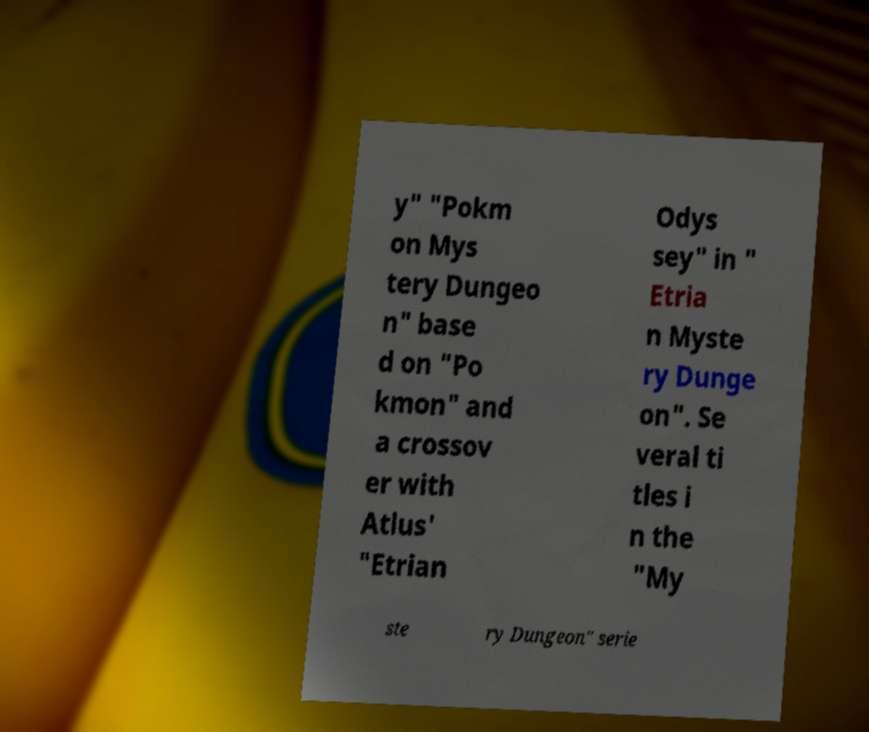Please read and relay the text visible in this image. What does it say? y" "Pokm on Mys tery Dungeo n" base d on "Po kmon" and a crossov er with Atlus' "Etrian Odys sey" in " Etria n Myste ry Dunge on". Se veral ti tles i n the "My ste ry Dungeon" serie 